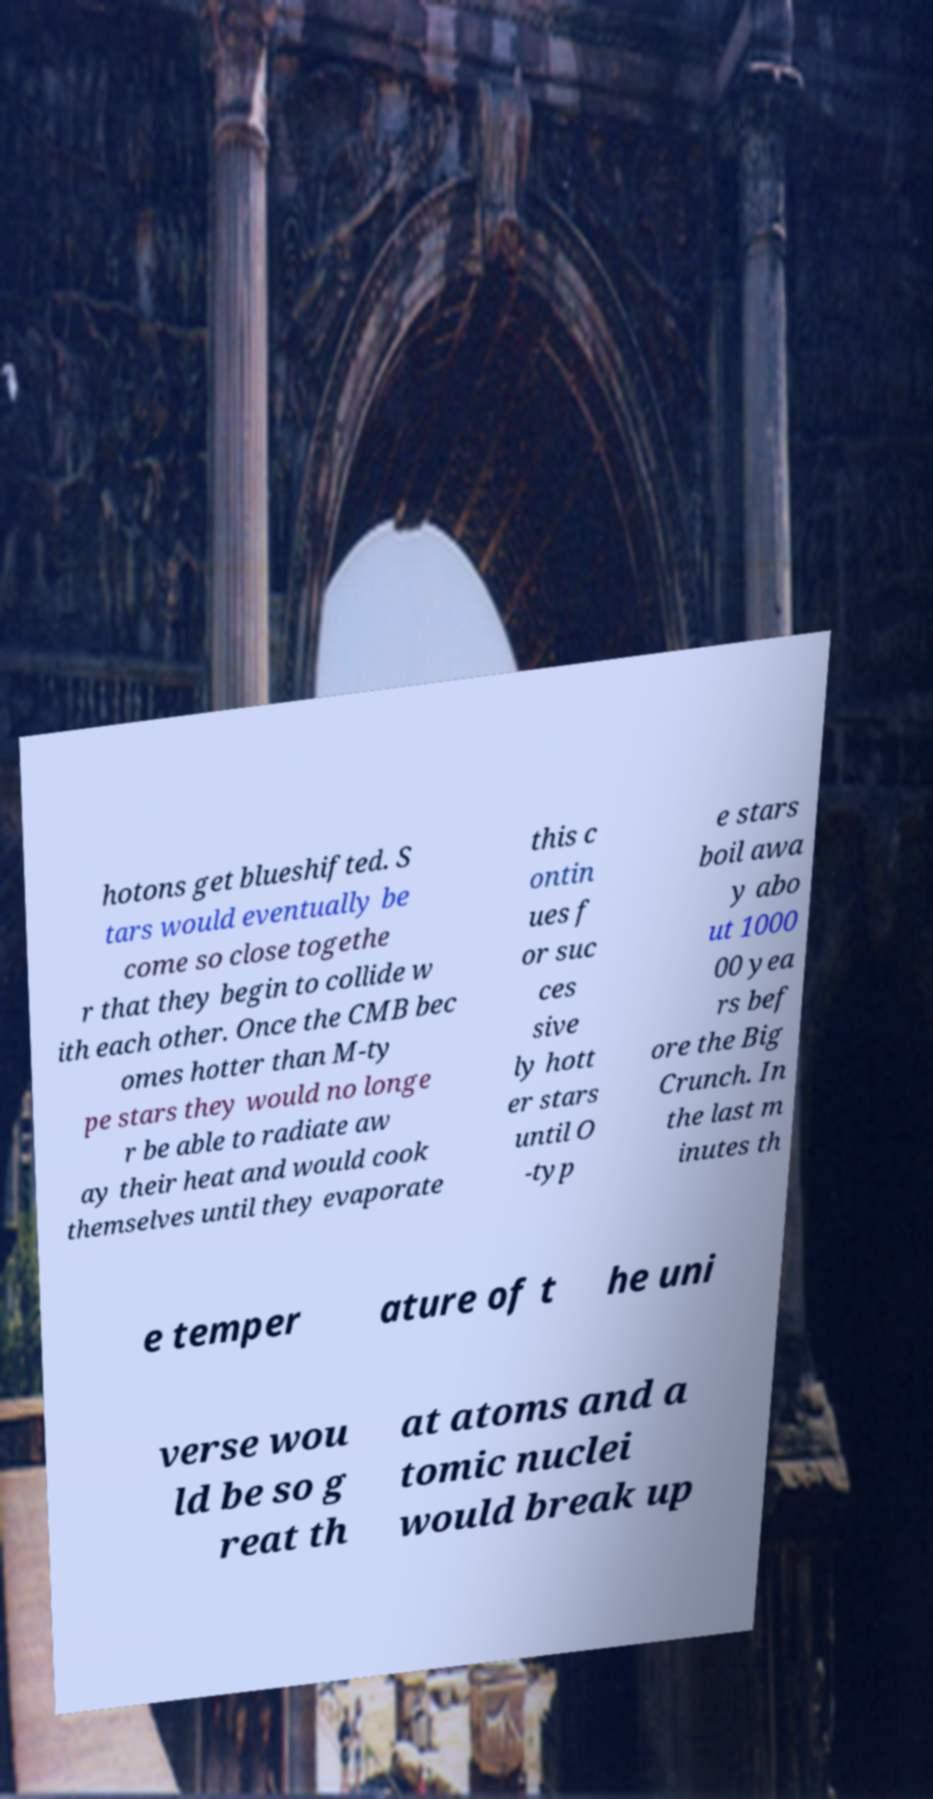For documentation purposes, I need the text within this image transcribed. Could you provide that? hotons get blueshifted. S tars would eventually be come so close togethe r that they begin to collide w ith each other. Once the CMB bec omes hotter than M-ty pe stars they would no longe r be able to radiate aw ay their heat and would cook themselves until they evaporate this c ontin ues f or suc ces sive ly hott er stars until O -typ e stars boil awa y abo ut 1000 00 yea rs bef ore the Big Crunch. In the last m inutes th e temper ature of t he uni verse wou ld be so g reat th at atoms and a tomic nuclei would break up 